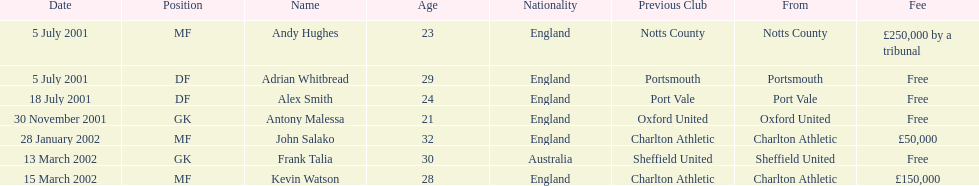List all the players names Andy Hughes, Adrian Whitbread, Alex Smith, Antony Malessa, John Salako, Frank Talia, Kevin Watson. Of these who is kevin watson Kevin Watson. To what transfer fee entry does kevin correspond to? £150,000. 